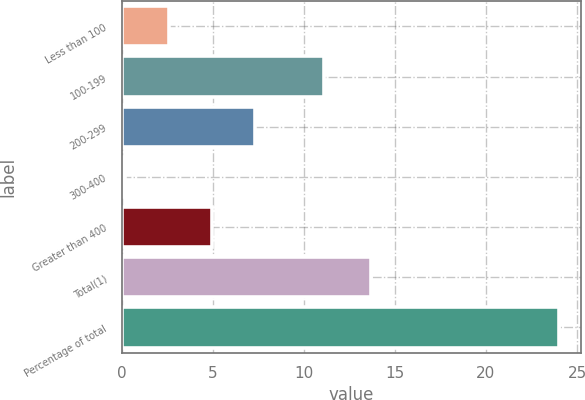Convert chart to OTSL. <chart><loc_0><loc_0><loc_500><loc_500><bar_chart><fcel>Less than 100<fcel>100-199<fcel>200-299<fcel>300-400<fcel>Greater than 400<fcel>Total(1)<fcel>Percentage of total<nl><fcel>2.58<fcel>11.1<fcel>7.34<fcel>0.2<fcel>4.96<fcel>13.7<fcel>24<nl></chart> 